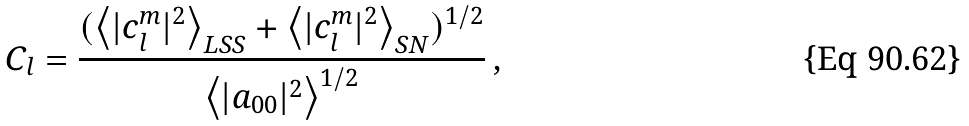Convert formula to latex. <formula><loc_0><loc_0><loc_500><loc_500>C _ { l } = \frac { ( \left < | c _ { l } ^ { m } | ^ { 2 } \right > _ { L S S } + \left < | c _ { l } ^ { m } | ^ { 2 } \right > _ { S N } ) ^ { 1 / 2 } } { \left < | a _ { 0 0 } | ^ { 2 } \right > ^ { 1 / 2 } } \, ,</formula> 